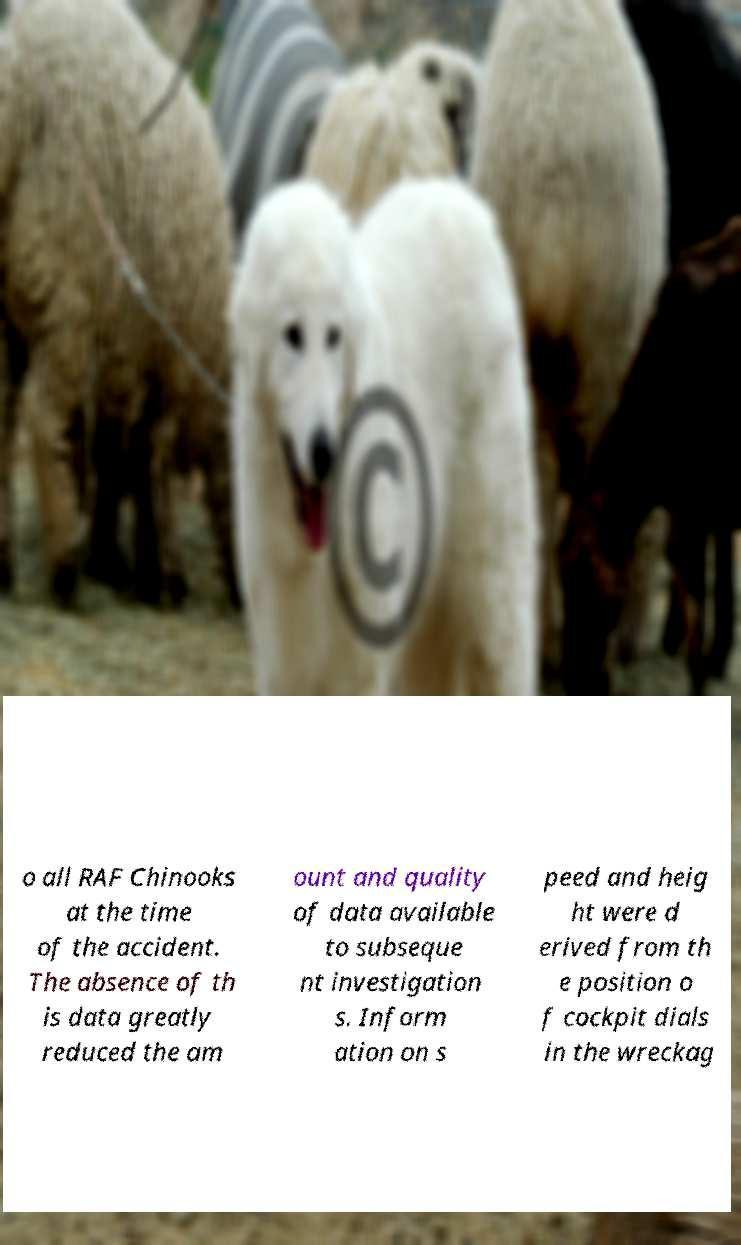Can you read and provide the text displayed in the image?This photo seems to have some interesting text. Can you extract and type it out for me? o all RAF Chinooks at the time of the accident. The absence of th is data greatly reduced the am ount and quality of data available to subseque nt investigation s. Inform ation on s peed and heig ht were d erived from th e position o f cockpit dials in the wreckag 